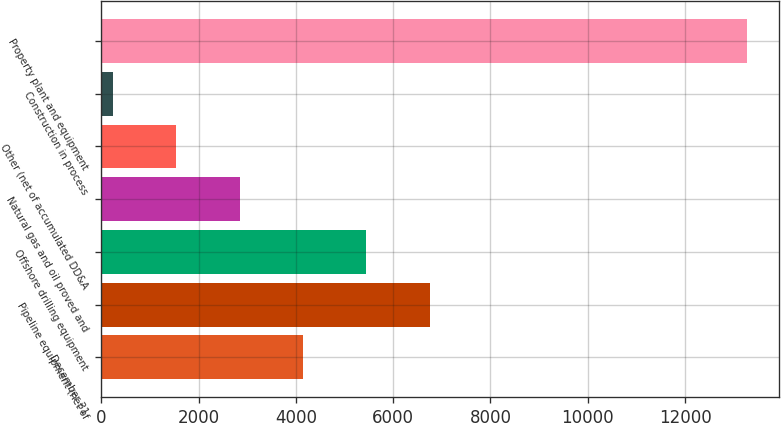Convert chart. <chart><loc_0><loc_0><loc_500><loc_500><bar_chart><fcel>December 31<fcel>Pipeline equipment (net of<fcel>Offshore drilling equipment<fcel>Natural gas and oil proved and<fcel>Other (net of accumulated DD&A<fcel>Construction in process<fcel>Property plant and equipment<nl><fcel>4146<fcel>6754<fcel>5450<fcel>2842<fcel>1538<fcel>234<fcel>13274<nl></chart> 